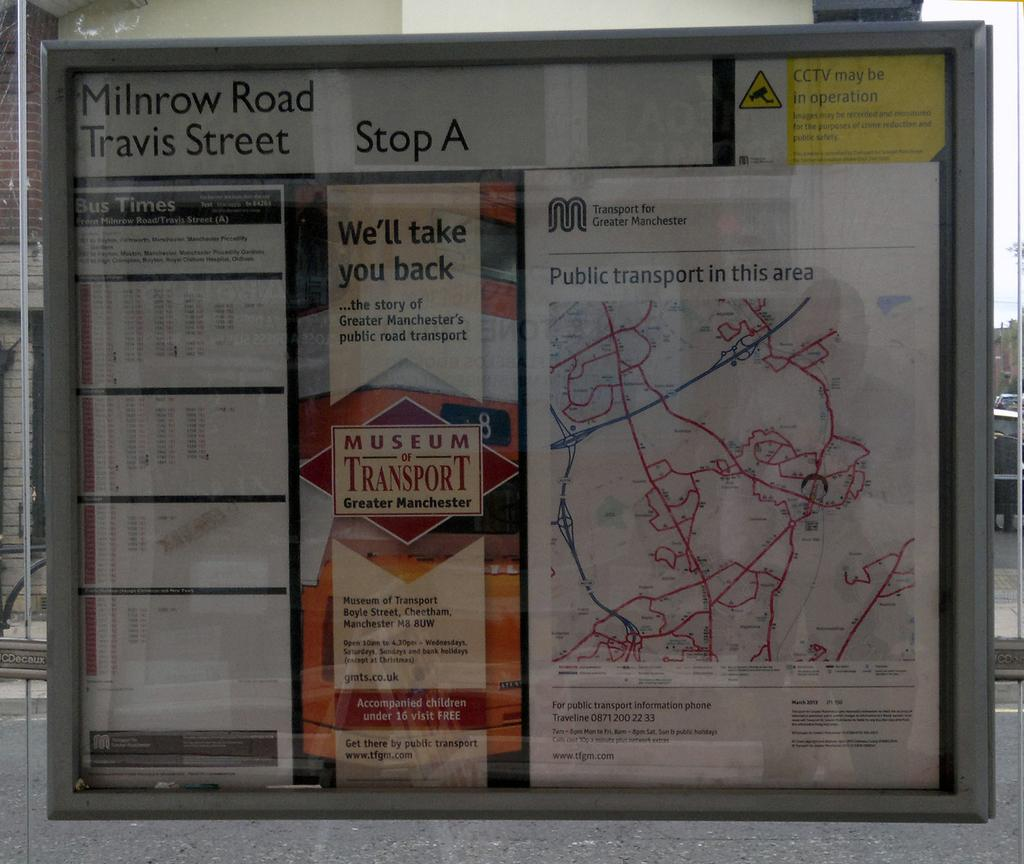<image>
Give a short and clear explanation of the subsequent image. A display board with Milnrow Road Travis Street written in black ink on top. 